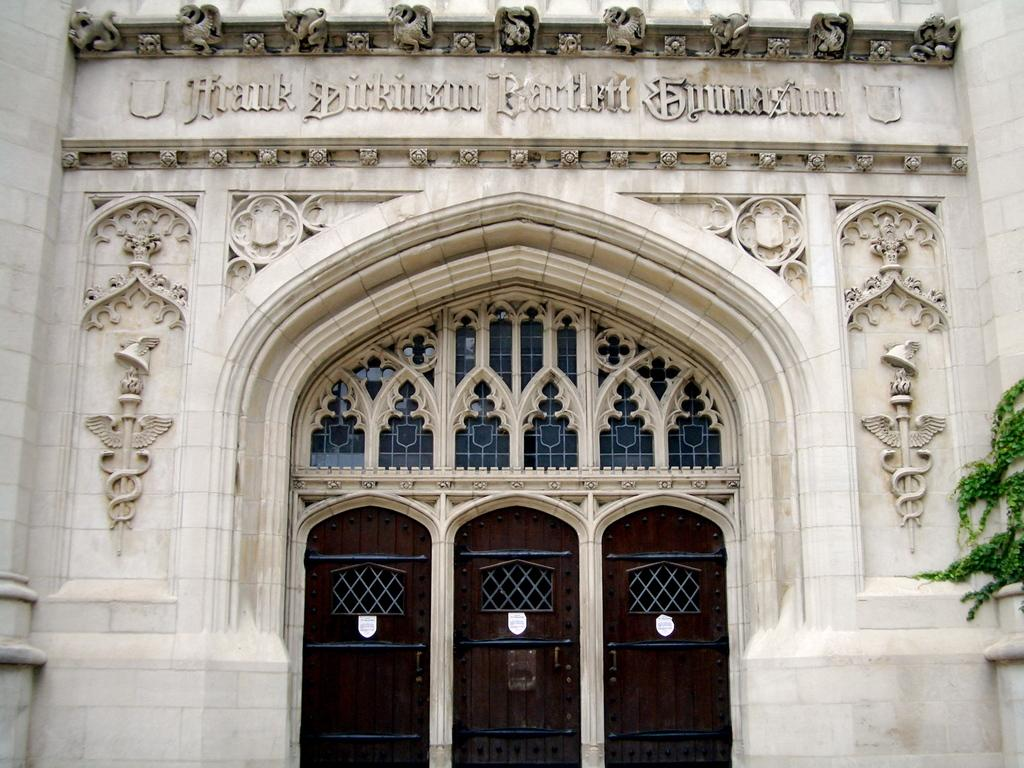What type of structure is present in the picture? There is a building in the picture. What feature of the building is mentioned in the facts? The building has a door. What additional object can be seen in the picture? There is a sculpture in the picture. What type of vegetation is present in the picture? There is a plant at the right side of the picture. Is there any text or label on the building? Yes, there is a name written on the building. What type of kettle is visible in the picture? There is no kettle present in the picture. Can you describe the curve of the sculpture in the picture? The facts provided do not mention any specific details about the sculpture's shape or curve. 